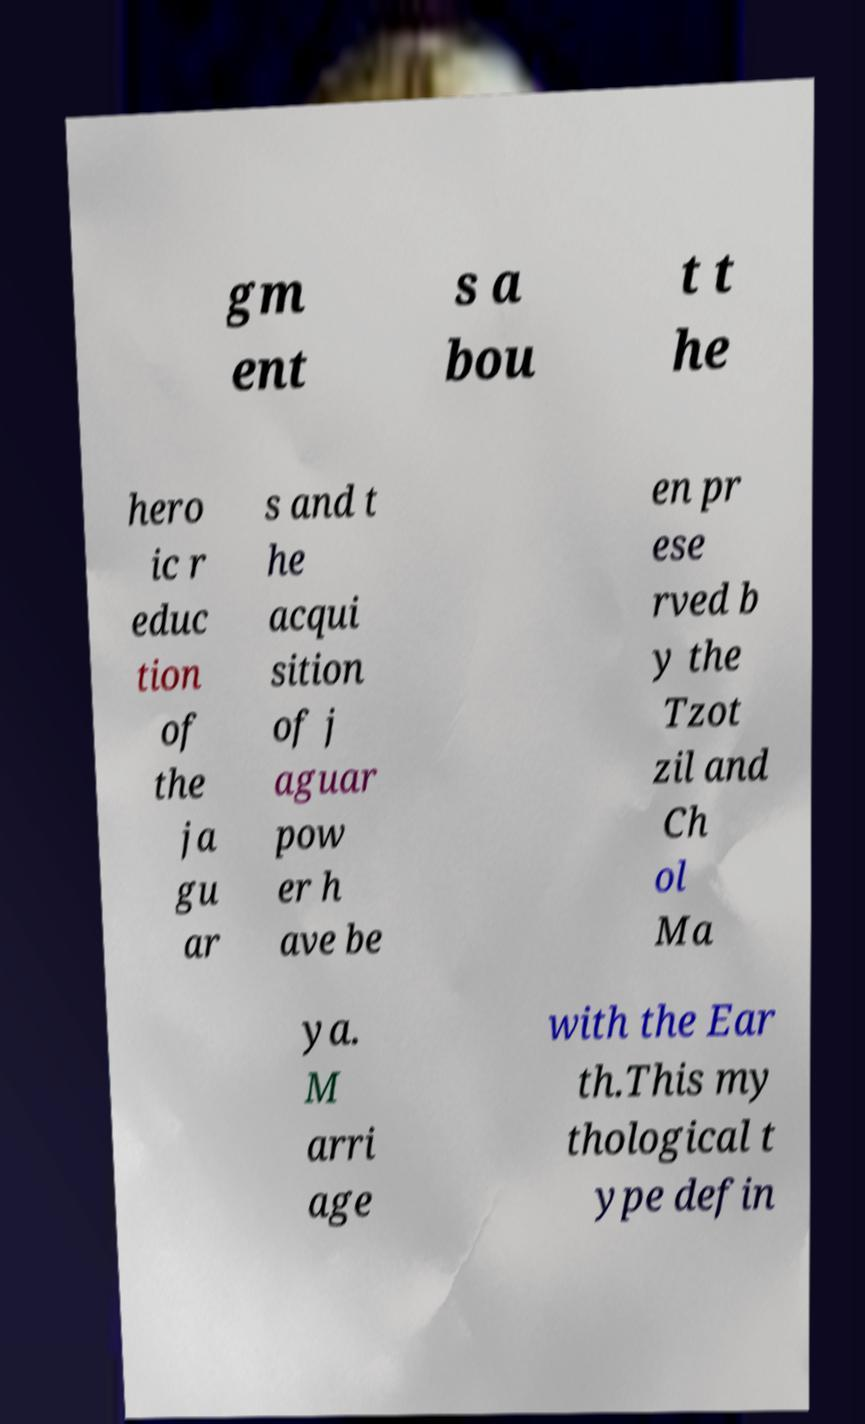I need the written content from this picture converted into text. Can you do that? gm ent s a bou t t he hero ic r educ tion of the ja gu ar s and t he acqui sition of j aguar pow er h ave be en pr ese rved b y the Tzot zil and Ch ol Ma ya. M arri age with the Ear th.This my thological t ype defin 